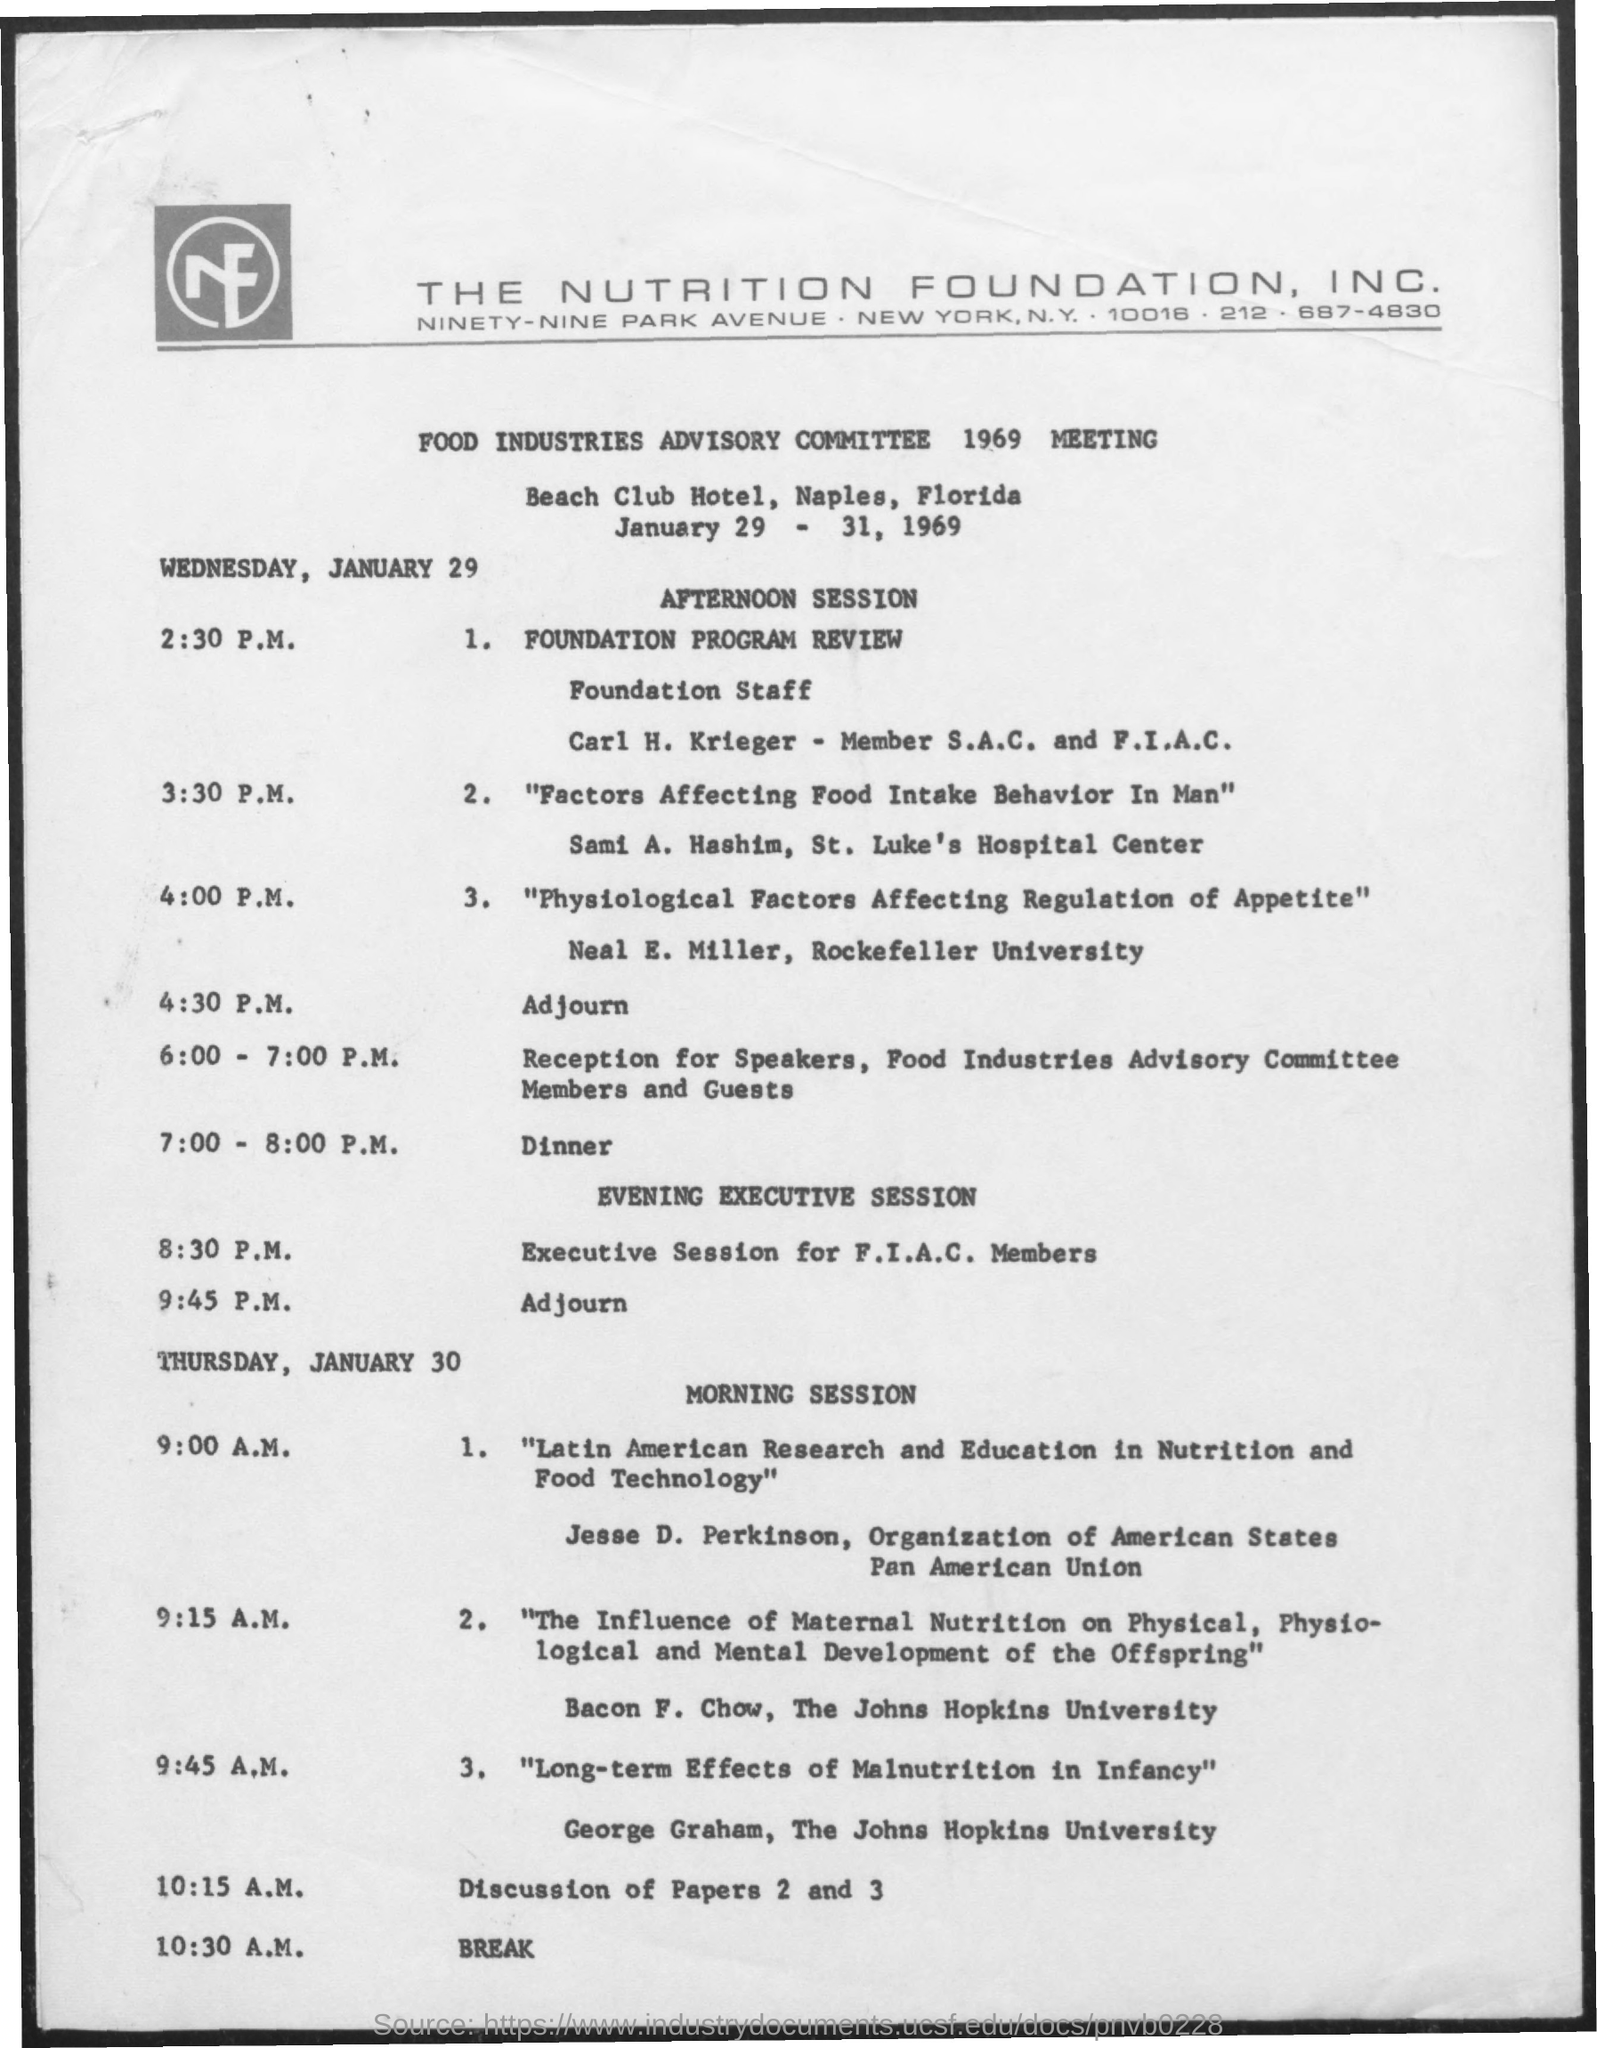Identify some key points in this picture. On Thursday, January 30, the break time is 10:30 A.M. The Beach Club Hotel is the name of the hotel that was mentioned. The Beach Club Hotel is located in Naples, Florida, which is the state where it is situated. The Nutrition Foundation, INC is located in New York City. The discussion of papers 2 and 3 will commence at 10:15 A.M. 